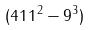<formula> <loc_0><loc_0><loc_500><loc_500>( 4 1 1 ^ { 2 } - 9 ^ { 3 } )</formula> 